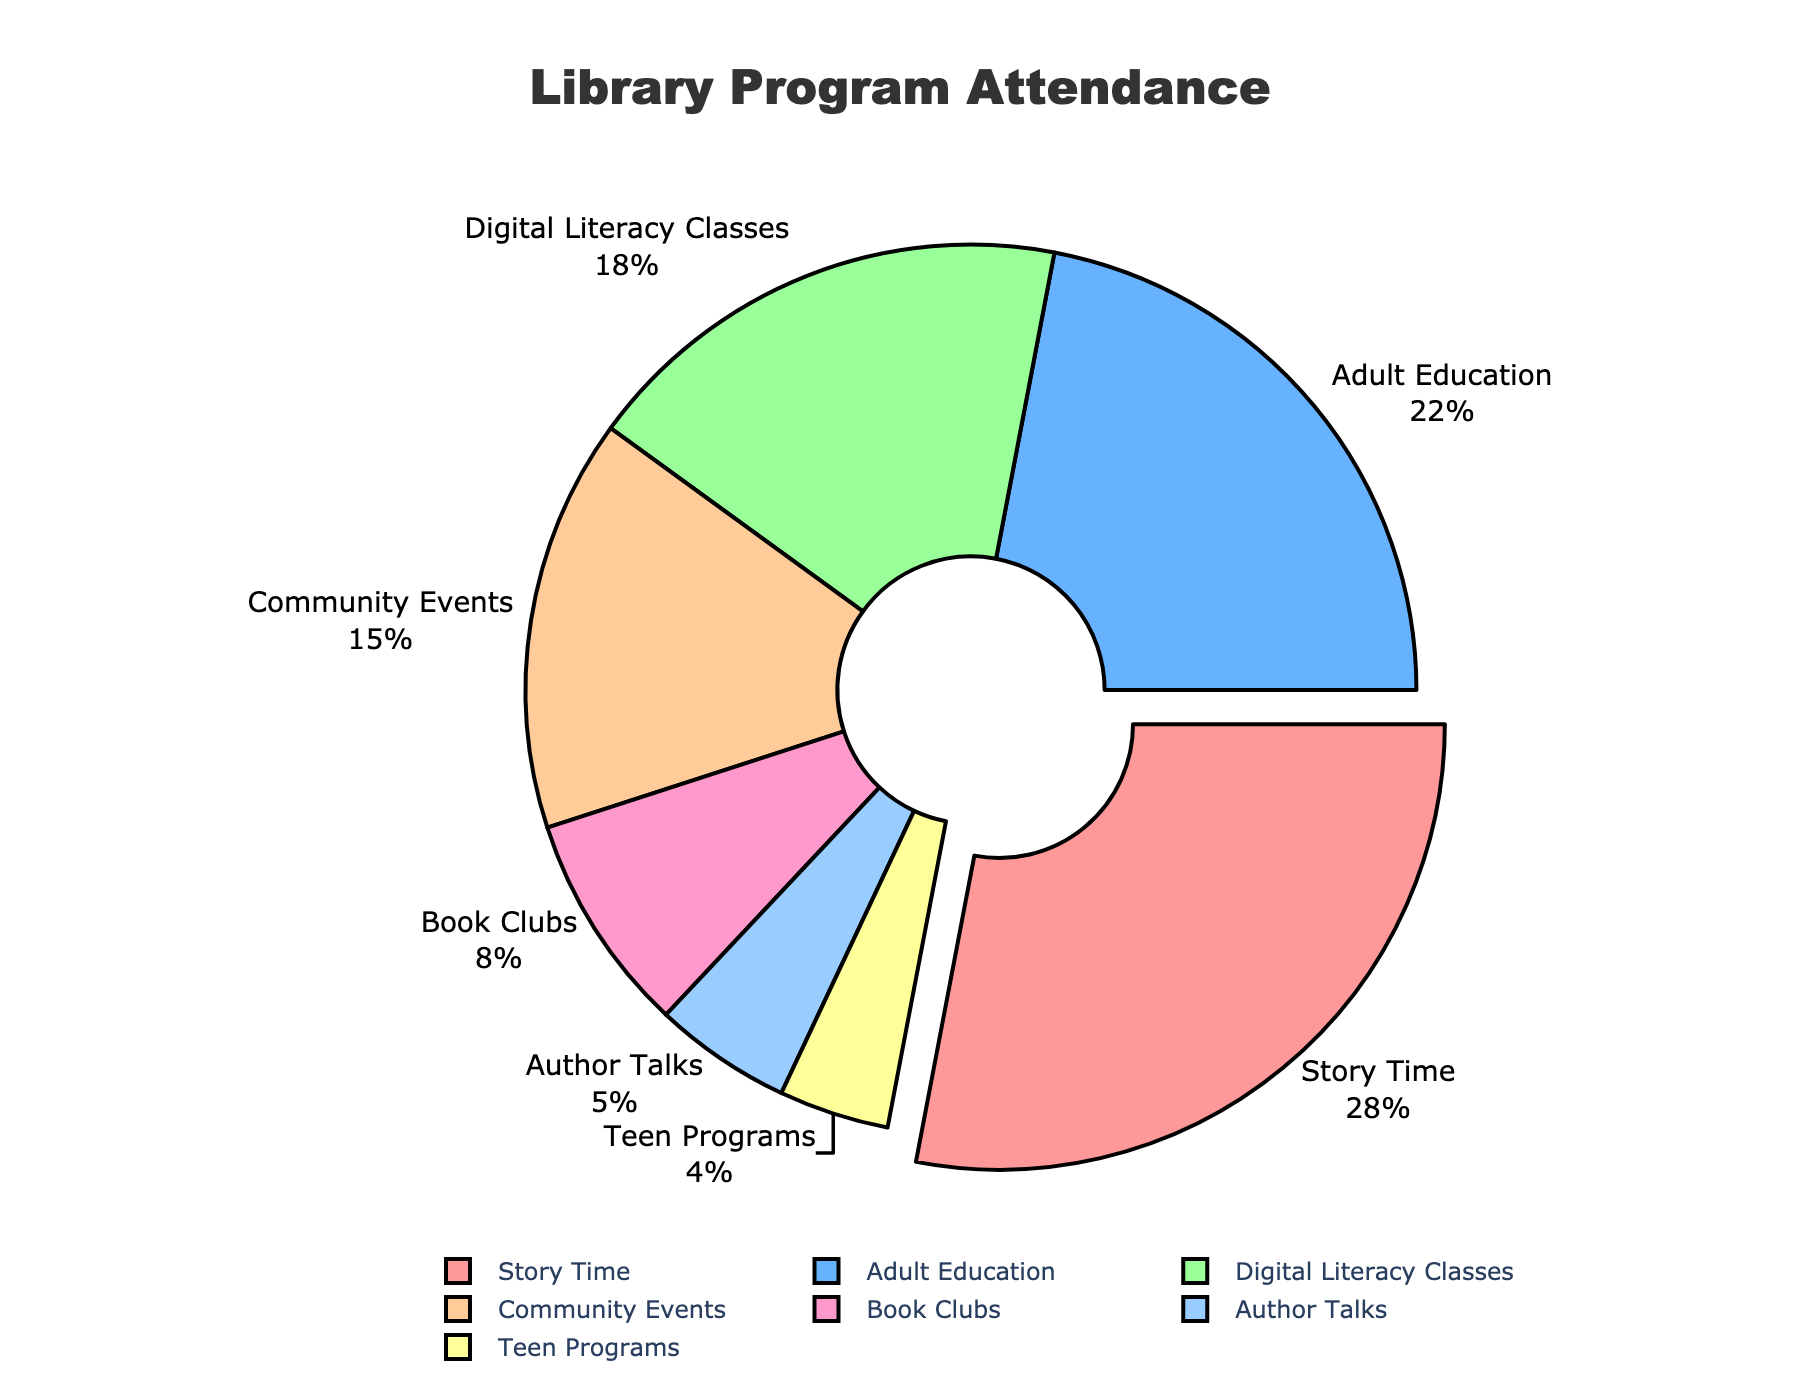What's the overall trend in violent crimes in Downtown over the years? Upon examining the scatter plot for Downtown, observe the trendline for violent crimes from 2018 to 2022. The data points show a decrease from 245 in 2018 to 210 in 2020, followed by a slight increase to 235 by 2022. Overall, the trend shows a decrease and then a minor increase in the last two years.
Answer: Decreasing slightly then increasing slightly How does the trend in property crimes in Riverside compare to Meadowbrook? Look at the scatter plots for Riverside and Meadowbrook. Riverside shows a slight decrease from 1450 in 2018 to 1420 in 2022, whereas Meadowbrook shows a mild increase from 1150 in 2018 to 1100 in 2022 after a dip to 1000 in 2020. Riverside has a relatively stable trend, while Meadowbrook sees a U-shaped trend.
Answer: Riverside relatively stable, Meadowbrook U-shaped Which neighborhood had the lowest incidence of violent crimes in 2020? Identify the data points for the year 2020 in each neighborhood. The values are Downtown (210), Riverside (160), Oakwood (85), Meadowbrook (105), and Hilltop (65). Hilltop has the lowest incidence of violent crimes in 2020.
Answer: Hilltop What was the highest number of property crimes reported in Oakwood and in which year did it occur? Analyze the scatter plot for Oakwood and identify the peak point among the data points for property crimes from 2018 to 2022. The highest number is 1020, reported in the year 2019.
Answer: 1020 in 2019 Compare the change in violent crimes between 2018 and 2022 across all neighborhoods. Calculate the difference between the values for 2018 and 2022 for each neighborhood: Downtown (245-235=10 decrease), Riverside (180-165=15 decrease), Oakwood (95-88=7 decrease), Meadowbrook (120-112=8 decrease), Hilltop (75-72=3 decrease). Downtown has the smallest decrease while Riverside has the largest decrease.
Answer: Downtown 10 decrease, Riverside largest 15 decrease, Oakwood 7 decrease, Meadowbrook 8 decrease, Hilltop 3 decrease What was the general trend in property crimes across Hilltop from 2018 to 2022? Look at the scatter plot for Hilltop. The data shows an initial increase from 820 in 2018 to 850 in 2019, followed by a decrease to 720 in 2020, and then it gradually rises again to 790 by 2022. The trend includes an initial rise, then a drop, followed by an increase.
Answer: Initially increase, then decrease, then increase Which year's data shows the lowest number of property crimes in Meadowbrook? Examine the scatter plot for Meadowbrook and identify the minimum value among the data points for property crimes from 2018 to 2022. The lowest value recorded is 1000 in the year 2020.
Answer: 2020 Between violent and property crimes, which category saw a more dramatic change in Downtown from 2018 to 2022? Compare the changes in numbers for violent crimes (245 in 2018 to 235 in 2022, a change of 10) and property crimes (1870 in 2018 to 1800 in 2022, a change of 70). Property crimes saw a more substantial change compared to violent crimes in Downtown.
Answer: Property crimes 